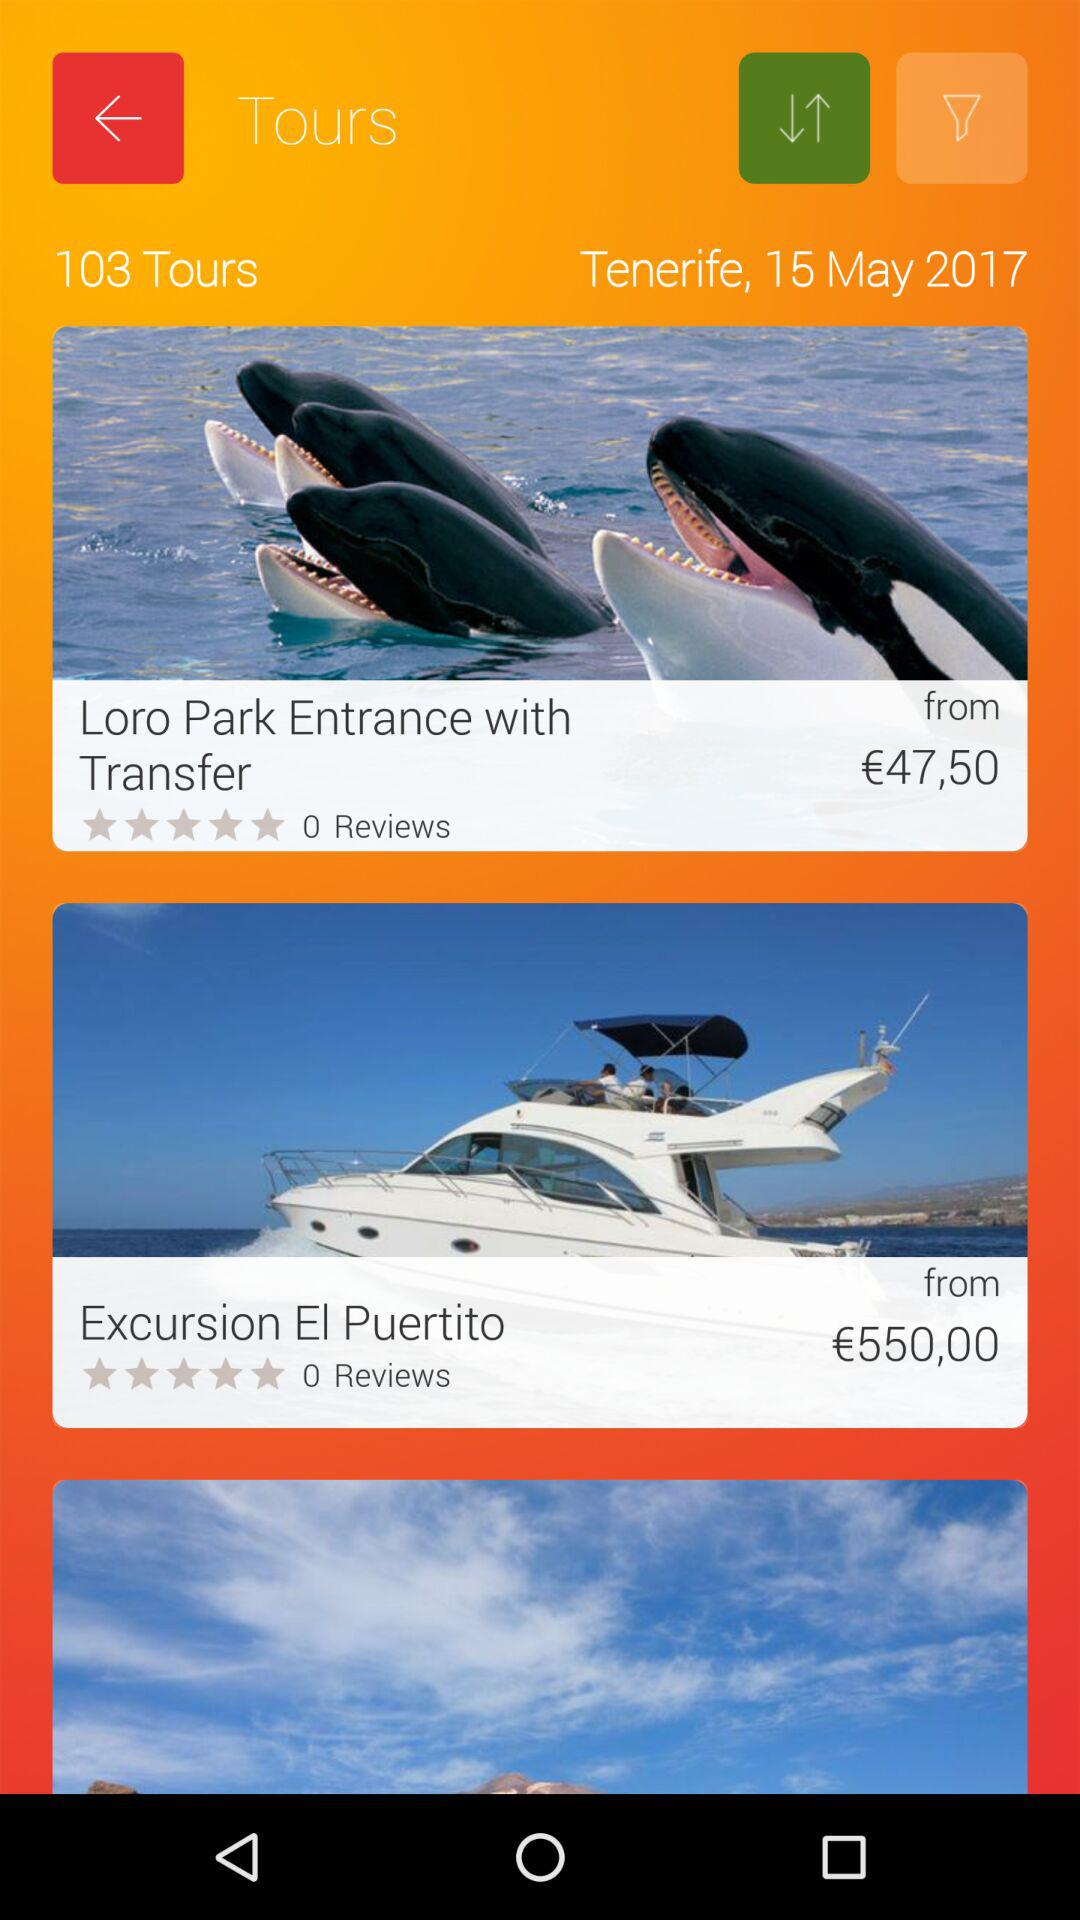How many tours were presented? There were 103 tours presented. 